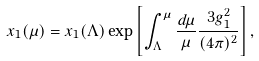Convert formula to latex. <formula><loc_0><loc_0><loc_500><loc_500>x _ { 1 } ( \mu ) = x _ { 1 } ( \Lambda ) \exp \left [ \int ^ { \mu } _ { \Lambda } \frac { d \mu } { \mu } \frac { 3 g _ { 1 } ^ { 2 } } { ( 4 \pi ) ^ { 2 } } \right ] ,</formula> 